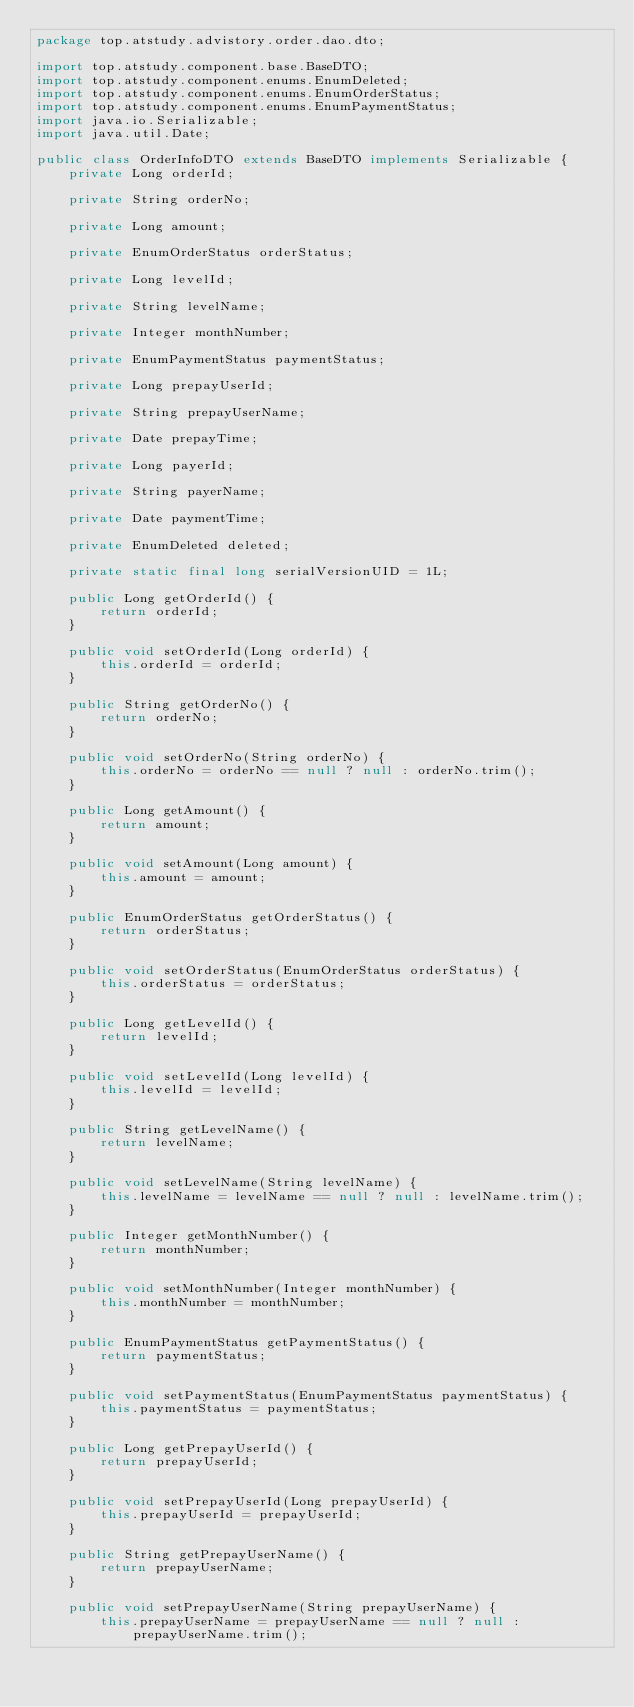Convert code to text. <code><loc_0><loc_0><loc_500><loc_500><_Java_>package top.atstudy.advistory.order.dao.dto;

import top.atstudy.component.base.BaseDTO;
import top.atstudy.component.enums.EnumDeleted;
import top.atstudy.component.enums.EnumOrderStatus;
import top.atstudy.component.enums.EnumPaymentStatus;
import java.io.Serializable;
import java.util.Date;

public class OrderInfoDTO extends BaseDTO implements Serializable {
    private Long orderId;

    private String orderNo;

    private Long amount;

    private EnumOrderStatus orderStatus;

    private Long levelId;

    private String levelName;

    private Integer monthNumber;

    private EnumPaymentStatus paymentStatus;

    private Long prepayUserId;

    private String prepayUserName;

    private Date prepayTime;

    private Long payerId;

    private String payerName;

    private Date paymentTime;

    private EnumDeleted deleted;

    private static final long serialVersionUID = 1L;

    public Long getOrderId() {
        return orderId;
    }

    public void setOrderId(Long orderId) {
        this.orderId = orderId;
    }

    public String getOrderNo() {
        return orderNo;
    }

    public void setOrderNo(String orderNo) {
        this.orderNo = orderNo == null ? null : orderNo.trim();
    }

    public Long getAmount() {
        return amount;
    }

    public void setAmount(Long amount) {
        this.amount = amount;
    }

    public EnumOrderStatus getOrderStatus() {
        return orderStatus;
    }

    public void setOrderStatus(EnumOrderStatus orderStatus) {
        this.orderStatus = orderStatus;
    }

    public Long getLevelId() {
        return levelId;
    }

    public void setLevelId(Long levelId) {
        this.levelId = levelId;
    }

    public String getLevelName() {
        return levelName;
    }

    public void setLevelName(String levelName) {
        this.levelName = levelName == null ? null : levelName.trim();
    }

    public Integer getMonthNumber() {
        return monthNumber;
    }

    public void setMonthNumber(Integer monthNumber) {
        this.monthNumber = monthNumber;
    }

    public EnumPaymentStatus getPaymentStatus() {
        return paymentStatus;
    }

    public void setPaymentStatus(EnumPaymentStatus paymentStatus) {
        this.paymentStatus = paymentStatus;
    }

    public Long getPrepayUserId() {
        return prepayUserId;
    }

    public void setPrepayUserId(Long prepayUserId) {
        this.prepayUserId = prepayUserId;
    }

    public String getPrepayUserName() {
        return prepayUserName;
    }

    public void setPrepayUserName(String prepayUserName) {
        this.prepayUserName = prepayUserName == null ? null : prepayUserName.trim();</code> 